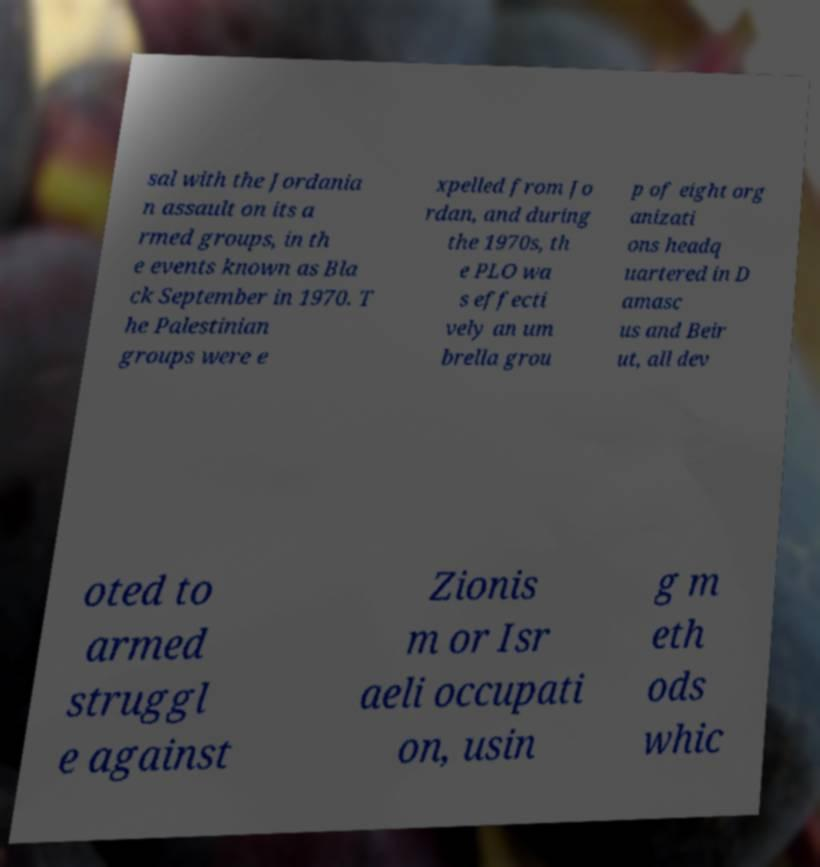Please identify and transcribe the text found in this image. sal with the Jordania n assault on its a rmed groups, in th e events known as Bla ck September in 1970. T he Palestinian groups were e xpelled from Jo rdan, and during the 1970s, th e PLO wa s effecti vely an um brella grou p of eight org anizati ons headq uartered in D amasc us and Beir ut, all dev oted to armed struggl e against Zionis m or Isr aeli occupati on, usin g m eth ods whic 